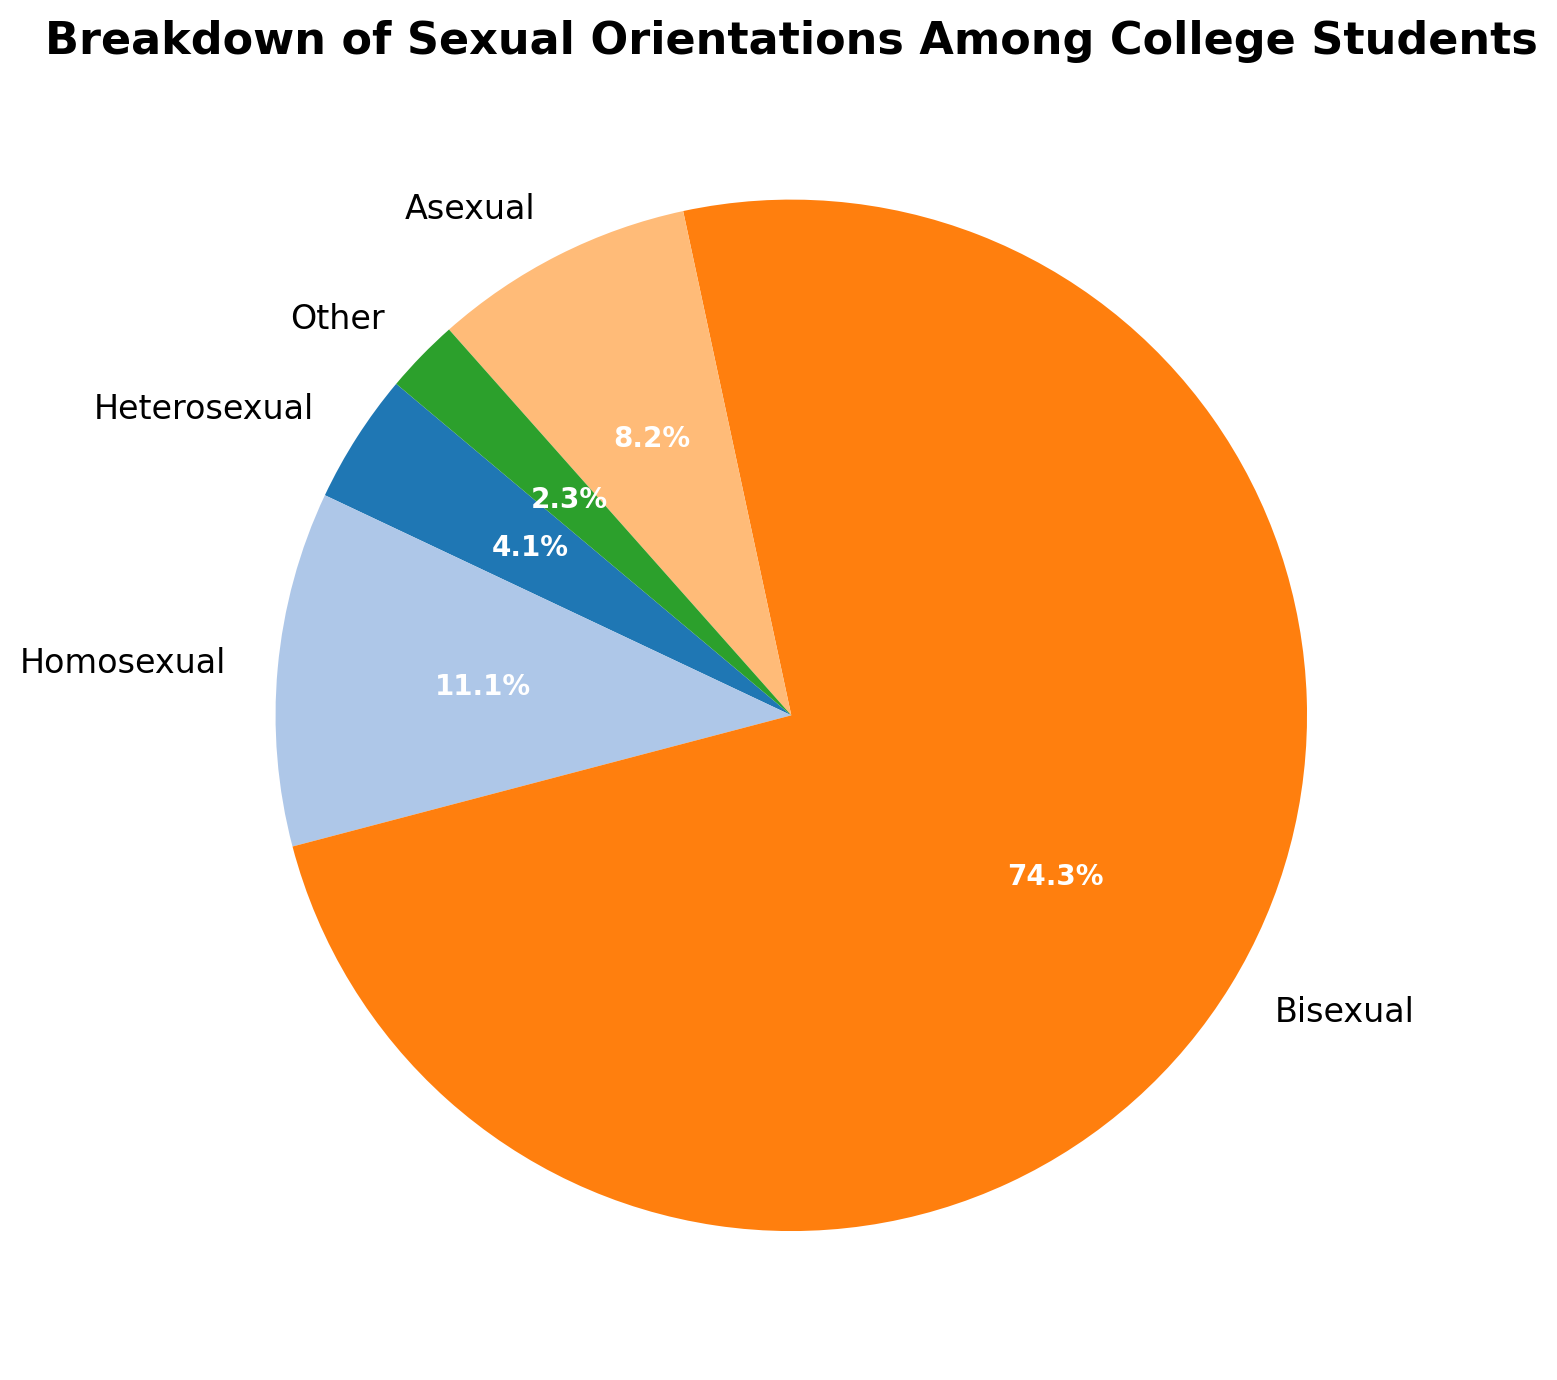What percentage of college students identify as bisexual? The figure shows a breakdown of percentages by sexual orientation. Locate the "Bisexual" section of the pie chart and note its percentage
Answer: 19% What is the most common sexual orientation among college students? The figure provides the numerical distribution for each sexual orientation. The largest percentage signifies the most common orientation, which is reflected on the biggest slice of the pie chart
Answer: Heterosexual How does the percentage of female bisexual students compare to male bisexual students? Locate the percentage slices for "Female: Bisexual" and "Male: Bisexual". Compare the two values to establish which is larger
Answer: The percentage of female bisexual students (10%) is higher than the percentage of male bisexual students (6%) Which sexual orientation has the smallest representation among college students? Examine the slices of the pie chart and find the smallest slice, representing the least percentage
Answer: Other (Non-Binary: 1%) Compare the combined percentage of asexual and other orientations to the percentage of homosexual orientations Sum the percentages of "Asexual" and "Other" and compare this value to the percentage of "Homosexual"
Answer: Combined total of asexual (7%) and other (4%) is 11%, which is more than the percentage of homosexual (14%) What is the total percentage of non-heterosexual orientations among college students? Non-heterosexual orientations include homosexual, bisexual, asexual, and other. Sum their respective percentages to get the total
Answer: (4 + 6 + 2 + 1) + (8 + 10 + 3 + 2) + (2 + 3 + 2 + 1) = 44% What percentage of heterosexual college students are non-binary? First, find the percentage of non-binary heterosexual students, then extract it from the total percentage of heterosexual students
Answer: 1% What is the difference between the percentages of male and female heterosexual students? Subtract the percentage of female heterosexual students from male heterosexual students
Answer: 68% - 58% = 10% What proportion of the pie chart's slices are dedicated to non-binary students? Add up the percentages for non-binary students, regardless of sexual orientation
Answer: 1 + 2 + 3 + 2 + 1 = 9% What is the most notable difference between male and female students in terms of sexual orientation percentages? Compare closely the specific orientation percentages between males and females to identify the most significant discrepancy
Answer: Female students have a notably higher percentage identifying as bisexual (10% vs 6% for males) 